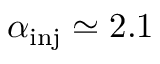<formula> <loc_0><loc_0><loc_500><loc_500>\alpha _ { i n j } \simeq 2 . 1</formula> 